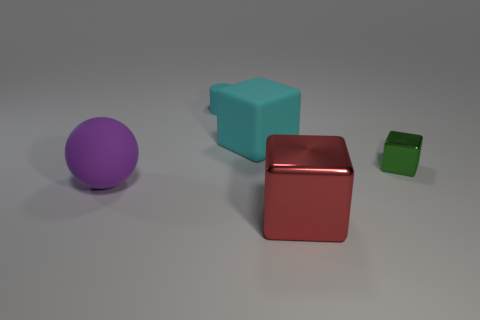Are there more tiny things that are left of the big shiny block than large purple objects that are to the right of the cyan cube?
Give a very brief answer. Yes. There is a tiny thing behind the green object; what shape is it?
Offer a very short reply. Cylinder. What is the size of the cylinder that is the same color as the large matte block?
Make the answer very short. Small. Is the material of the large object to the left of the cylinder the same as the red block?
Provide a succinct answer. No. Is the number of small metal blocks to the left of the big cyan block the same as the number of rubber cubes that are behind the big purple sphere?
Make the answer very short. No. There is a rubber object that is behind the purple rubber sphere and in front of the tiny matte thing; what shape is it?
Your answer should be very brief. Cube. There is a matte object that is behind the rubber ball and in front of the tiny cylinder; what is its size?
Keep it short and to the point. Large. There is a block that is to the left of the metallic cube left of the metal block that is behind the large shiny block; what size is it?
Make the answer very short. Large. The purple object is what size?
Your answer should be very brief. Large. Is there a rubber block in front of the shiny thing right of the large thing that is in front of the big purple rubber sphere?
Offer a terse response. No. 